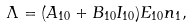Convert formula to latex. <formula><loc_0><loc_0><loc_500><loc_500>\Lambda = ( A _ { 1 0 } + B _ { 1 0 } I _ { 1 0 } ) E _ { 1 0 } n _ { 1 } ,</formula> 